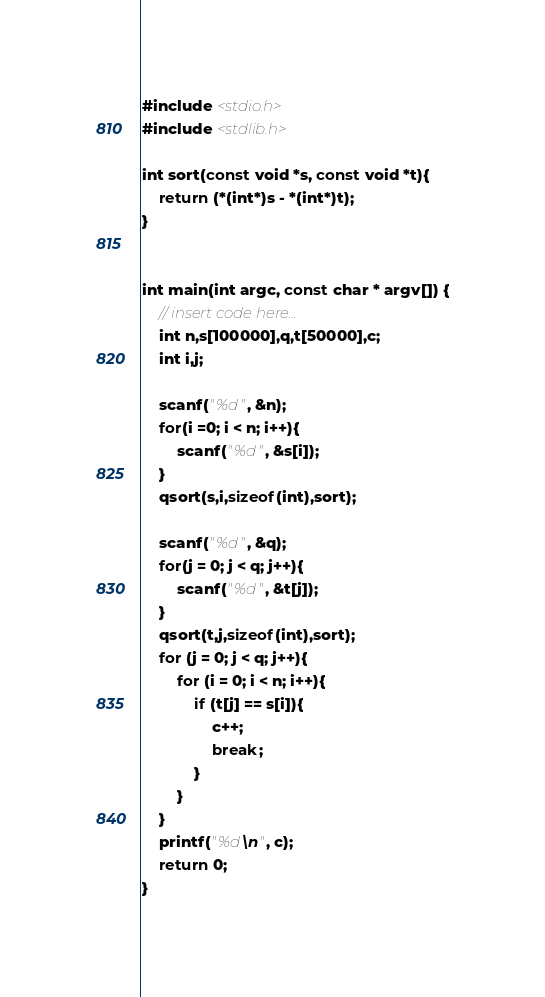Convert code to text. <code><loc_0><loc_0><loc_500><loc_500><_C_>#include <stdio.h>
#include <stdlib.h>

int sort(const void *s, const void *t){
    return (*(int*)s - *(int*)t);
}


int main(int argc, const char * argv[]) {
    // insert code here...
    int n,s[100000],q,t[50000],c;
    int i,j;
    
    scanf("%d", &n);
    for(i =0; i < n; i++){
        scanf("%d", &s[i]);
    }
    qsort(s,i,sizeof(int),sort);
    
    scanf("%d", &q);
    for(j = 0; j < q; j++){
        scanf("%d", &t[j]);
    }
    qsort(t,j,sizeof(int),sort);
    for (j = 0; j < q; j++){
        for (i = 0; i < n; i++){
            if (t[j] == s[i]){
                c++;
                break;
            }
        }
    }
    printf("%d\n", c);
    return 0;
}</code> 